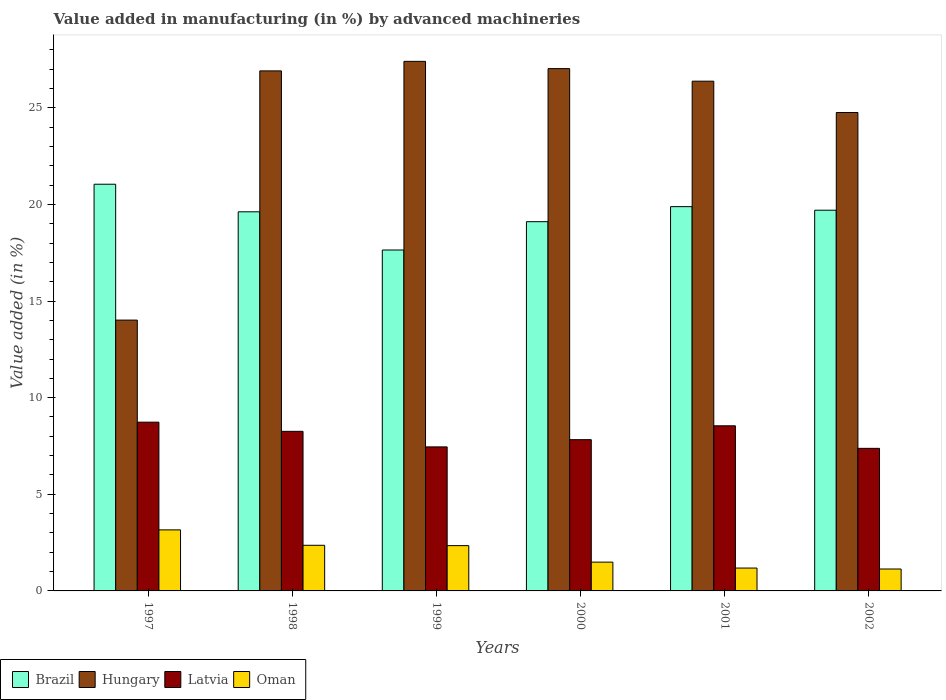How many different coloured bars are there?
Ensure brevity in your answer.  4. How many groups of bars are there?
Provide a short and direct response. 6. Are the number of bars on each tick of the X-axis equal?
Ensure brevity in your answer.  Yes. What is the label of the 1st group of bars from the left?
Make the answer very short. 1997. In how many cases, is the number of bars for a given year not equal to the number of legend labels?
Offer a very short reply. 0. What is the percentage of value added in manufacturing by advanced machineries in Oman in 1997?
Offer a terse response. 3.16. Across all years, what is the maximum percentage of value added in manufacturing by advanced machineries in Latvia?
Provide a succinct answer. 8.73. Across all years, what is the minimum percentage of value added in manufacturing by advanced machineries in Brazil?
Your response must be concise. 17.64. In which year was the percentage of value added in manufacturing by advanced machineries in Brazil maximum?
Provide a succinct answer. 1997. In which year was the percentage of value added in manufacturing by advanced machineries in Brazil minimum?
Make the answer very short. 1999. What is the total percentage of value added in manufacturing by advanced machineries in Oman in the graph?
Give a very brief answer. 11.67. What is the difference between the percentage of value added in manufacturing by advanced machineries in Hungary in 1997 and that in 2002?
Give a very brief answer. -10.74. What is the difference between the percentage of value added in manufacturing by advanced machineries in Hungary in 2001 and the percentage of value added in manufacturing by advanced machineries in Oman in 2002?
Provide a succinct answer. 25.24. What is the average percentage of value added in manufacturing by advanced machineries in Latvia per year?
Your answer should be very brief. 8.03. In the year 2000, what is the difference between the percentage of value added in manufacturing by advanced machineries in Oman and percentage of value added in manufacturing by advanced machineries in Hungary?
Offer a terse response. -25.54. In how many years, is the percentage of value added in manufacturing by advanced machineries in Oman greater than 25 %?
Provide a succinct answer. 0. What is the ratio of the percentage of value added in manufacturing by advanced machineries in Oman in 1997 to that in 1999?
Your response must be concise. 1.35. What is the difference between the highest and the second highest percentage of value added in manufacturing by advanced machineries in Brazil?
Your response must be concise. 1.16. What is the difference between the highest and the lowest percentage of value added in manufacturing by advanced machineries in Brazil?
Your response must be concise. 3.4. Is the sum of the percentage of value added in manufacturing by advanced machineries in Hungary in 1999 and 2000 greater than the maximum percentage of value added in manufacturing by advanced machineries in Oman across all years?
Make the answer very short. Yes. Is it the case that in every year, the sum of the percentage of value added in manufacturing by advanced machineries in Oman and percentage of value added in manufacturing by advanced machineries in Hungary is greater than the sum of percentage of value added in manufacturing by advanced machineries in Brazil and percentage of value added in manufacturing by advanced machineries in Latvia?
Offer a terse response. No. What does the 3rd bar from the left in 2000 represents?
Offer a terse response. Latvia. What does the 1st bar from the right in 2002 represents?
Your answer should be compact. Oman. Are all the bars in the graph horizontal?
Provide a short and direct response. No. How many years are there in the graph?
Your answer should be very brief. 6. Are the values on the major ticks of Y-axis written in scientific E-notation?
Your answer should be very brief. No. How are the legend labels stacked?
Your answer should be very brief. Horizontal. What is the title of the graph?
Offer a terse response. Value added in manufacturing (in %) by advanced machineries. Does "Bosnia and Herzegovina" appear as one of the legend labels in the graph?
Make the answer very short. No. What is the label or title of the X-axis?
Offer a very short reply. Years. What is the label or title of the Y-axis?
Ensure brevity in your answer.  Value added (in %). What is the Value added (in %) in Brazil in 1997?
Your answer should be compact. 21.04. What is the Value added (in %) in Hungary in 1997?
Provide a short and direct response. 14.01. What is the Value added (in %) of Latvia in 1997?
Keep it short and to the point. 8.73. What is the Value added (in %) of Oman in 1997?
Offer a very short reply. 3.16. What is the Value added (in %) in Brazil in 1998?
Offer a terse response. 19.62. What is the Value added (in %) in Hungary in 1998?
Keep it short and to the point. 26.91. What is the Value added (in %) of Latvia in 1998?
Your answer should be compact. 8.26. What is the Value added (in %) of Oman in 1998?
Offer a terse response. 2.36. What is the Value added (in %) in Brazil in 1999?
Your answer should be very brief. 17.64. What is the Value added (in %) in Hungary in 1999?
Ensure brevity in your answer.  27.4. What is the Value added (in %) of Latvia in 1999?
Your answer should be compact. 7.45. What is the Value added (in %) of Oman in 1999?
Ensure brevity in your answer.  2.34. What is the Value added (in %) of Brazil in 2000?
Keep it short and to the point. 19.11. What is the Value added (in %) of Hungary in 2000?
Your answer should be compact. 27.03. What is the Value added (in %) in Latvia in 2000?
Make the answer very short. 7.83. What is the Value added (in %) in Oman in 2000?
Provide a succinct answer. 1.49. What is the Value added (in %) in Brazil in 2001?
Offer a terse response. 19.88. What is the Value added (in %) of Hungary in 2001?
Your answer should be very brief. 26.38. What is the Value added (in %) of Latvia in 2001?
Provide a succinct answer. 8.54. What is the Value added (in %) of Oman in 2001?
Your answer should be compact. 1.18. What is the Value added (in %) in Brazil in 2002?
Your answer should be very brief. 19.7. What is the Value added (in %) of Hungary in 2002?
Your answer should be compact. 24.76. What is the Value added (in %) of Latvia in 2002?
Provide a short and direct response. 7.38. What is the Value added (in %) in Oman in 2002?
Your response must be concise. 1.13. Across all years, what is the maximum Value added (in %) in Brazil?
Offer a very short reply. 21.04. Across all years, what is the maximum Value added (in %) in Hungary?
Keep it short and to the point. 27.4. Across all years, what is the maximum Value added (in %) in Latvia?
Your answer should be very brief. 8.73. Across all years, what is the maximum Value added (in %) in Oman?
Make the answer very short. 3.16. Across all years, what is the minimum Value added (in %) of Brazil?
Provide a short and direct response. 17.64. Across all years, what is the minimum Value added (in %) in Hungary?
Make the answer very short. 14.01. Across all years, what is the minimum Value added (in %) of Latvia?
Your answer should be very brief. 7.38. Across all years, what is the minimum Value added (in %) of Oman?
Ensure brevity in your answer.  1.13. What is the total Value added (in %) of Brazil in the graph?
Provide a succinct answer. 116.99. What is the total Value added (in %) of Hungary in the graph?
Provide a short and direct response. 146.48. What is the total Value added (in %) of Latvia in the graph?
Ensure brevity in your answer.  48.19. What is the total Value added (in %) of Oman in the graph?
Offer a very short reply. 11.67. What is the difference between the Value added (in %) of Brazil in 1997 and that in 1998?
Your answer should be compact. 1.43. What is the difference between the Value added (in %) of Hungary in 1997 and that in 1998?
Give a very brief answer. -12.9. What is the difference between the Value added (in %) of Latvia in 1997 and that in 1998?
Your answer should be very brief. 0.47. What is the difference between the Value added (in %) in Oman in 1997 and that in 1998?
Give a very brief answer. 0.8. What is the difference between the Value added (in %) in Brazil in 1997 and that in 1999?
Ensure brevity in your answer.  3.4. What is the difference between the Value added (in %) of Hungary in 1997 and that in 1999?
Keep it short and to the point. -13.39. What is the difference between the Value added (in %) of Latvia in 1997 and that in 1999?
Make the answer very short. 1.28. What is the difference between the Value added (in %) of Oman in 1997 and that in 1999?
Make the answer very short. 0.82. What is the difference between the Value added (in %) in Brazil in 1997 and that in 2000?
Your response must be concise. 1.94. What is the difference between the Value added (in %) of Hungary in 1997 and that in 2000?
Make the answer very short. -13.01. What is the difference between the Value added (in %) of Latvia in 1997 and that in 2000?
Your answer should be compact. 0.91. What is the difference between the Value added (in %) in Oman in 1997 and that in 2000?
Keep it short and to the point. 1.67. What is the difference between the Value added (in %) of Brazil in 1997 and that in 2001?
Offer a terse response. 1.16. What is the difference between the Value added (in %) of Hungary in 1997 and that in 2001?
Provide a short and direct response. -12.36. What is the difference between the Value added (in %) in Latvia in 1997 and that in 2001?
Provide a short and direct response. 0.19. What is the difference between the Value added (in %) of Oman in 1997 and that in 2001?
Your answer should be compact. 1.98. What is the difference between the Value added (in %) in Brazil in 1997 and that in 2002?
Your answer should be compact. 1.34. What is the difference between the Value added (in %) in Hungary in 1997 and that in 2002?
Keep it short and to the point. -10.74. What is the difference between the Value added (in %) of Latvia in 1997 and that in 2002?
Make the answer very short. 1.35. What is the difference between the Value added (in %) of Oman in 1997 and that in 2002?
Your response must be concise. 2.03. What is the difference between the Value added (in %) of Brazil in 1998 and that in 1999?
Offer a terse response. 1.98. What is the difference between the Value added (in %) of Hungary in 1998 and that in 1999?
Your answer should be compact. -0.49. What is the difference between the Value added (in %) of Latvia in 1998 and that in 1999?
Your answer should be compact. 0.8. What is the difference between the Value added (in %) of Oman in 1998 and that in 1999?
Give a very brief answer. 0.02. What is the difference between the Value added (in %) of Brazil in 1998 and that in 2000?
Offer a terse response. 0.51. What is the difference between the Value added (in %) of Hungary in 1998 and that in 2000?
Keep it short and to the point. -0.12. What is the difference between the Value added (in %) in Latvia in 1998 and that in 2000?
Provide a short and direct response. 0.43. What is the difference between the Value added (in %) of Oman in 1998 and that in 2000?
Provide a short and direct response. 0.87. What is the difference between the Value added (in %) of Brazil in 1998 and that in 2001?
Make the answer very short. -0.27. What is the difference between the Value added (in %) in Hungary in 1998 and that in 2001?
Offer a terse response. 0.53. What is the difference between the Value added (in %) in Latvia in 1998 and that in 2001?
Give a very brief answer. -0.29. What is the difference between the Value added (in %) of Oman in 1998 and that in 2001?
Provide a succinct answer. 1.18. What is the difference between the Value added (in %) of Brazil in 1998 and that in 2002?
Give a very brief answer. -0.08. What is the difference between the Value added (in %) in Hungary in 1998 and that in 2002?
Offer a very short reply. 2.15. What is the difference between the Value added (in %) in Latvia in 1998 and that in 2002?
Your answer should be compact. 0.88. What is the difference between the Value added (in %) in Oman in 1998 and that in 2002?
Make the answer very short. 1.23. What is the difference between the Value added (in %) in Brazil in 1999 and that in 2000?
Your answer should be very brief. -1.47. What is the difference between the Value added (in %) of Hungary in 1999 and that in 2000?
Provide a succinct answer. 0.38. What is the difference between the Value added (in %) in Latvia in 1999 and that in 2000?
Make the answer very short. -0.37. What is the difference between the Value added (in %) in Oman in 1999 and that in 2000?
Offer a very short reply. 0.85. What is the difference between the Value added (in %) of Brazil in 1999 and that in 2001?
Your response must be concise. -2.24. What is the difference between the Value added (in %) in Hungary in 1999 and that in 2001?
Make the answer very short. 1.03. What is the difference between the Value added (in %) of Latvia in 1999 and that in 2001?
Make the answer very short. -1.09. What is the difference between the Value added (in %) of Oman in 1999 and that in 2001?
Offer a very short reply. 1.16. What is the difference between the Value added (in %) of Brazil in 1999 and that in 2002?
Offer a terse response. -2.06. What is the difference between the Value added (in %) in Hungary in 1999 and that in 2002?
Provide a succinct answer. 2.65. What is the difference between the Value added (in %) of Latvia in 1999 and that in 2002?
Keep it short and to the point. 0.08. What is the difference between the Value added (in %) in Oman in 1999 and that in 2002?
Your answer should be compact. 1.21. What is the difference between the Value added (in %) of Brazil in 2000 and that in 2001?
Your answer should be very brief. -0.78. What is the difference between the Value added (in %) in Hungary in 2000 and that in 2001?
Provide a short and direct response. 0.65. What is the difference between the Value added (in %) in Latvia in 2000 and that in 2001?
Provide a succinct answer. -0.72. What is the difference between the Value added (in %) in Oman in 2000 and that in 2001?
Ensure brevity in your answer.  0.31. What is the difference between the Value added (in %) in Brazil in 2000 and that in 2002?
Offer a very short reply. -0.59. What is the difference between the Value added (in %) of Hungary in 2000 and that in 2002?
Provide a short and direct response. 2.27. What is the difference between the Value added (in %) in Latvia in 2000 and that in 2002?
Your response must be concise. 0.45. What is the difference between the Value added (in %) of Oman in 2000 and that in 2002?
Your response must be concise. 0.36. What is the difference between the Value added (in %) of Brazil in 2001 and that in 2002?
Provide a short and direct response. 0.18. What is the difference between the Value added (in %) in Hungary in 2001 and that in 2002?
Give a very brief answer. 1.62. What is the difference between the Value added (in %) in Latvia in 2001 and that in 2002?
Your answer should be compact. 1.17. What is the difference between the Value added (in %) in Brazil in 1997 and the Value added (in %) in Hungary in 1998?
Your response must be concise. -5.86. What is the difference between the Value added (in %) in Brazil in 1997 and the Value added (in %) in Latvia in 1998?
Your answer should be very brief. 12.79. What is the difference between the Value added (in %) in Brazil in 1997 and the Value added (in %) in Oman in 1998?
Offer a very short reply. 18.68. What is the difference between the Value added (in %) in Hungary in 1997 and the Value added (in %) in Latvia in 1998?
Your answer should be very brief. 5.76. What is the difference between the Value added (in %) of Hungary in 1997 and the Value added (in %) of Oman in 1998?
Provide a succinct answer. 11.65. What is the difference between the Value added (in %) in Latvia in 1997 and the Value added (in %) in Oman in 1998?
Ensure brevity in your answer.  6.37. What is the difference between the Value added (in %) in Brazil in 1997 and the Value added (in %) in Hungary in 1999?
Your response must be concise. -6.36. What is the difference between the Value added (in %) of Brazil in 1997 and the Value added (in %) of Latvia in 1999?
Give a very brief answer. 13.59. What is the difference between the Value added (in %) of Brazil in 1997 and the Value added (in %) of Oman in 1999?
Ensure brevity in your answer.  18.7. What is the difference between the Value added (in %) in Hungary in 1997 and the Value added (in %) in Latvia in 1999?
Ensure brevity in your answer.  6.56. What is the difference between the Value added (in %) in Hungary in 1997 and the Value added (in %) in Oman in 1999?
Your answer should be very brief. 11.67. What is the difference between the Value added (in %) in Latvia in 1997 and the Value added (in %) in Oman in 1999?
Provide a succinct answer. 6.39. What is the difference between the Value added (in %) in Brazil in 1997 and the Value added (in %) in Hungary in 2000?
Give a very brief answer. -5.98. What is the difference between the Value added (in %) of Brazil in 1997 and the Value added (in %) of Latvia in 2000?
Offer a terse response. 13.22. What is the difference between the Value added (in %) of Brazil in 1997 and the Value added (in %) of Oman in 2000?
Keep it short and to the point. 19.56. What is the difference between the Value added (in %) in Hungary in 1997 and the Value added (in %) in Latvia in 2000?
Offer a terse response. 6.19. What is the difference between the Value added (in %) in Hungary in 1997 and the Value added (in %) in Oman in 2000?
Provide a succinct answer. 12.52. What is the difference between the Value added (in %) in Latvia in 1997 and the Value added (in %) in Oman in 2000?
Provide a short and direct response. 7.24. What is the difference between the Value added (in %) in Brazil in 1997 and the Value added (in %) in Hungary in 2001?
Your answer should be compact. -5.33. What is the difference between the Value added (in %) of Brazil in 1997 and the Value added (in %) of Latvia in 2001?
Keep it short and to the point. 12.5. What is the difference between the Value added (in %) in Brazil in 1997 and the Value added (in %) in Oman in 2001?
Give a very brief answer. 19.86. What is the difference between the Value added (in %) in Hungary in 1997 and the Value added (in %) in Latvia in 2001?
Give a very brief answer. 5.47. What is the difference between the Value added (in %) in Hungary in 1997 and the Value added (in %) in Oman in 2001?
Make the answer very short. 12.83. What is the difference between the Value added (in %) of Latvia in 1997 and the Value added (in %) of Oman in 2001?
Offer a very short reply. 7.55. What is the difference between the Value added (in %) of Brazil in 1997 and the Value added (in %) of Hungary in 2002?
Ensure brevity in your answer.  -3.71. What is the difference between the Value added (in %) of Brazil in 1997 and the Value added (in %) of Latvia in 2002?
Offer a terse response. 13.67. What is the difference between the Value added (in %) of Brazil in 1997 and the Value added (in %) of Oman in 2002?
Provide a short and direct response. 19.91. What is the difference between the Value added (in %) of Hungary in 1997 and the Value added (in %) of Latvia in 2002?
Provide a short and direct response. 6.64. What is the difference between the Value added (in %) of Hungary in 1997 and the Value added (in %) of Oman in 2002?
Your answer should be very brief. 12.88. What is the difference between the Value added (in %) of Latvia in 1997 and the Value added (in %) of Oman in 2002?
Ensure brevity in your answer.  7.6. What is the difference between the Value added (in %) in Brazil in 1998 and the Value added (in %) in Hungary in 1999?
Make the answer very short. -7.79. What is the difference between the Value added (in %) of Brazil in 1998 and the Value added (in %) of Latvia in 1999?
Offer a terse response. 12.16. What is the difference between the Value added (in %) in Brazil in 1998 and the Value added (in %) in Oman in 1999?
Offer a terse response. 17.27. What is the difference between the Value added (in %) in Hungary in 1998 and the Value added (in %) in Latvia in 1999?
Your response must be concise. 19.46. What is the difference between the Value added (in %) of Hungary in 1998 and the Value added (in %) of Oman in 1999?
Make the answer very short. 24.57. What is the difference between the Value added (in %) in Latvia in 1998 and the Value added (in %) in Oman in 1999?
Offer a very short reply. 5.91. What is the difference between the Value added (in %) in Brazil in 1998 and the Value added (in %) in Hungary in 2000?
Your answer should be very brief. -7.41. What is the difference between the Value added (in %) in Brazil in 1998 and the Value added (in %) in Latvia in 2000?
Ensure brevity in your answer.  11.79. What is the difference between the Value added (in %) of Brazil in 1998 and the Value added (in %) of Oman in 2000?
Ensure brevity in your answer.  18.13. What is the difference between the Value added (in %) of Hungary in 1998 and the Value added (in %) of Latvia in 2000?
Make the answer very short. 19.08. What is the difference between the Value added (in %) in Hungary in 1998 and the Value added (in %) in Oman in 2000?
Provide a succinct answer. 25.42. What is the difference between the Value added (in %) of Latvia in 1998 and the Value added (in %) of Oman in 2000?
Keep it short and to the point. 6.77. What is the difference between the Value added (in %) in Brazil in 1998 and the Value added (in %) in Hungary in 2001?
Your response must be concise. -6.76. What is the difference between the Value added (in %) in Brazil in 1998 and the Value added (in %) in Latvia in 2001?
Offer a terse response. 11.07. What is the difference between the Value added (in %) in Brazil in 1998 and the Value added (in %) in Oman in 2001?
Your answer should be very brief. 18.43. What is the difference between the Value added (in %) of Hungary in 1998 and the Value added (in %) of Latvia in 2001?
Ensure brevity in your answer.  18.36. What is the difference between the Value added (in %) in Hungary in 1998 and the Value added (in %) in Oman in 2001?
Give a very brief answer. 25.73. What is the difference between the Value added (in %) in Latvia in 1998 and the Value added (in %) in Oman in 2001?
Your answer should be compact. 7.07. What is the difference between the Value added (in %) of Brazil in 1998 and the Value added (in %) of Hungary in 2002?
Offer a very short reply. -5.14. What is the difference between the Value added (in %) in Brazil in 1998 and the Value added (in %) in Latvia in 2002?
Your answer should be very brief. 12.24. What is the difference between the Value added (in %) in Brazil in 1998 and the Value added (in %) in Oman in 2002?
Keep it short and to the point. 18.48. What is the difference between the Value added (in %) of Hungary in 1998 and the Value added (in %) of Latvia in 2002?
Your answer should be compact. 19.53. What is the difference between the Value added (in %) of Hungary in 1998 and the Value added (in %) of Oman in 2002?
Keep it short and to the point. 25.78. What is the difference between the Value added (in %) in Latvia in 1998 and the Value added (in %) in Oman in 2002?
Provide a short and direct response. 7.12. What is the difference between the Value added (in %) in Brazil in 1999 and the Value added (in %) in Hungary in 2000?
Your response must be concise. -9.39. What is the difference between the Value added (in %) of Brazil in 1999 and the Value added (in %) of Latvia in 2000?
Keep it short and to the point. 9.81. What is the difference between the Value added (in %) of Brazil in 1999 and the Value added (in %) of Oman in 2000?
Provide a succinct answer. 16.15. What is the difference between the Value added (in %) in Hungary in 1999 and the Value added (in %) in Latvia in 2000?
Your response must be concise. 19.58. What is the difference between the Value added (in %) of Hungary in 1999 and the Value added (in %) of Oman in 2000?
Provide a succinct answer. 25.91. What is the difference between the Value added (in %) of Latvia in 1999 and the Value added (in %) of Oman in 2000?
Your response must be concise. 5.96. What is the difference between the Value added (in %) in Brazil in 1999 and the Value added (in %) in Hungary in 2001?
Provide a short and direct response. -8.74. What is the difference between the Value added (in %) of Brazil in 1999 and the Value added (in %) of Latvia in 2001?
Your answer should be very brief. 9.1. What is the difference between the Value added (in %) of Brazil in 1999 and the Value added (in %) of Oman in 2001?
Provide a short and direct response. 16.46. What is the difference between the Value added (in %) of Hungary in 1999 and the Value added (in %) of Latvia in 2001?
Provide a succinct answer. 18.86. What is the difference between the Value added (in %) in Hungary in 1999 and the Value added (in %) in Oman in 2001?
Your answer should be compact. 26.22. What is the difference between the Value added (in %) of Latvia in 1999 and the Value added (in %) of Oman in 2001?
Make the answer very short. 6.27. What is the difference between the Value added (in %) of Brazil in 1999 and the Value added (in %) of Hungary in 2002?
Provide a short and direct response. -7.12. What is the difference between the Value added (in %) of Brazil in 1999 and the Value added (in %) of Latvia in 2002?
Keep it short and to the point. 10.26. What is the difference between the Value added (in %) in Brazil in 1999 and the Value added (in %) in Oman in 2002?
Make the answer very short. 16.51. What is the difference between the Value added (in %) in Hungary in 1999 and the Value added (in %) in Latvia in 2002?
Offer a terse response. 20.02. What is the difference between the Value added (in %) in Hungary in 1999 and the Value added (in %) in Oman in 2002?
Offer a terse response. 26.27. What is the difference between the Value added (in %) in Latvia in 1999 and the Value added (in %) in Oman in 2002?
Your response must be concise. 6.32. What is the difference between the Value added (in %) in Brazil in 2000 and the Value added (in %) in Hungary in 2001?
Your response must be concise. -7.27. What is the difference between the Value added (in %) of Brazil in 2000 and the Value added (in %) of Latvia in 2001?
Your answer should be compact. 10.56. What is the difference between the Value added (in %) in Brazil in 2000 and the Value added (in %) in Oman in 2001?
Your answer should be very brief. 17.92. What is the difference between the Value added (in %) in Hungary in 2000 and the Value added (in %) in Latvia in 2001?
Provide a short and direct response. 18.48. What is the difference between the Value added (in %) of Hungary in 2000 and the Value added (in %) of Oman in 2001?
Make the answer very short. 25.84. What is the difference between the Value added (in %) of Latvia in 2000 and the Value added (in %) of Oman in 2001?
Ensure brevity in your answer.  6.64. What is the difference between the Value added (in %) in Brazil in 2000 and the Value added (in %) in Hungary in 2002?
Offer a very short reply. -5.65. What is the difference between the Value added (in %) of Brazil in 2000 and the Value added (in %) of Latvia in 2002?
Your answer should be very brief. 11.73. What is the difference between the Value added (in %) of Brazil in 2000 and the Value added (in %) of Oman in 2002?
Your answer should be very brief. 17.97. What is the difference between the Value added (in %) of Hungary in 2000 and the Value added (in %) of Latvia in 2002?
Give a very brief answer. 19.65. What is the difference between the Value added (in %) in Hungary in 2000 and the Value added (in %) in Oman in 2002?
Give a very brief answer. 25.89. What is the difference between the Value added (in %) in Latvia in 2000 and the Value added (in %) in Oman in 2002?
Offer a very short reply. 6.69. What is the difference between the Value added (in %) in Brazil in 2001 and the Value added (in %) in Hungary in 2002?
Keep it short and to the point. -4.87. What is the difference between the Value added (in %) of Brazil in 2001 and the Value added (in %) of Latvia in 2002?
Your response must be concise. 12.51. What is the difference between the Value added (in %) of Brazil in 2001 and the Value added (in %) of Oman in 2002?
Make the answer very short. 18.75. What is the difference between the Value added (in %) of Hungary in 2001 and the Value added (in %) of Latvia in 2002?
Offer a terse response. 19. What is the difference between the Value added (in %) in Hungary in 2001 and the Value added (in %) in Oman in 2002?
Make the answer very short. 25.24. What is the difference between the Value added (in %) of Latvia in 2001 and the Value added (in %) of Oman in 2002?
Your response must be concise. 7.41. What is the average Value added (in %) of Brazil per year?
Make the answer very short. 19.5. What is the average Value added (in %) in Hungary per year?
Offer a terse response. 24.41. What is the average Value added (in %) in Latvia per year?
Your answer should be compact. 8.03. What is the average Value added (in %) in Oman per year?
Offer a terse response. 1.94. In the year 1997, what is the difference between the Value added (in %) in Brazil and Value added (in %) in Hungary?
Offer a terse response. 7.03. In the year 1997, what is the difference between the Value added (in %) in Brazil and Value added (in %) in Latvia?
Make the answer very short. 12.31. In the year 1997, what is the difference between the Value added (in %) of Brazil and Value added (in %) of Oman?
Your answer should be compact. 17.89. In the year 1997, what is the difference between the Value added (in %) of Hungary and Value added (in %) of Latvia?
Make the answer very short. 5.28. In the year 1997, what is the difference between the Value added (in %) of Hungary and Value added (in %) of Oman?
Provide a succinct answer. 10.85. In the year 1997, what is the difference between the Value added (in %) in Latvia and Value added (in %) in Oman?
Keep it short and to the point. 5.57. In the year 1998, what is the difference between the Value added (in %) of Brazil and Value added (in %) of Hungary?
Offer a very short reply. -7.29. In the year 1998, what is the difference between the Value added (in %) of Brazil and Value added (in %) of Latvia?
Your answer should be very brief. 11.36. In the year 1998, what is the difference between the Value added (in %) of Brazil and Value added (in %) of Oman?
Ensure brevity in your answer.  17.26. In the year 1998, what is the difference between the Value added (in %) in Hungary and Value added (in %) in Latvia?
Your answer should be compact. 18.65. In the year 1998, what is the difference between the Value added (in %) in Hungary and Value added (in %) in Oman?
Make the answer very short. 24.55. In the year 1998, what is the difference between the Value added (in %) in Latvia and Value added (in %) in Oman?
Offer a very short reply. 5.9. In the year 1999, what is the difference between the Value added (in %) in Brazil and Value added (in %) in Hungary?
Your answer should be very brief. -9.76. In the year 1999, what is the difference between the Value added (in %) of Brazil and Value added (in %) of Latvia?
Keep it short and to the point. 10.19. In the year 1999, what is the difference between the Value added (in %) of Brazil and Value added (in %) of Oman?
Give a very brief answer. 15.3. In the year 1999, what is the difference between the Value added (in %) of Hungary and Value added (in %) of Latvia?
Your answer should be very brief. 19.95. In the year 1999, what is the difference between the Value added (in %) in Hungary and Value added (in %) in Oman?
Keep it short and to the point. 25.06. In the year 1999, what is the difference between the Value added (in %) of Latvia and Value added (in %) of Oman?
Offer a very short reply. 5.11. In the year 2000, what is the difference between the Value added (in %) of Brazil and Value added (in %) of Hungary?
Provide a succinct answer. -7.92. In the year 2000, what is the difference between the Value added (in %) of Brazil and Value added (in %) of Latvia?
Ensure brevity in your answer.  11.28. In the year 2000, what is the difference between the Value added (in %) of Brazil and Value added (in %) of Oman?
Provide a succinct answer. 17.62. In the year 2000, what is the difference between the Value added (in %) in Hungary and Value added (in %) in Latvia?
Offer a terse response. 19.2. In the year 2000, what is the difference between the Value added (in %) of Hungary and Value added (in %) of Oman?
Ensure brevity in your answer.  25.54. In the year 2000, what is the difference between the Value added (in %) in Latvia and Value added (in %) in Oman?
Your answer should be compact. 6.34. In the year 2001, what is the difference between the Value added (in %) in Brazil and Value added (in %) in Hungary?
Ensure brevity in your answer.  -6.49. In the year 2001, what is the difference between the Value added (in %) of Brazil and Value added (in %) of Latvia?
Ensure brevity in your answer.  11.34. In the year 2001, what is the difference between the Value added (in %) of Brazil and Value added (in %) of Oman?
Make the answer very short. 18.7. In the year 2001, what is the difference between the Value added (in %) of Hungary and Value added (in %) of Latvia?
Offer a terse response. 17.83. In the year 2001, what is the difference between the Value added (in %) in Hungary and Value added (in %) in Oman?
Give a very brief answer. 25.19. In the year 2001, what is the difference between the Value added (in %) of Latvia and Value added (in %) of Oman?
Your response must be concise. 7.36. In the year 2002, what is the difference between the Value added (in %) of Brazil and Value added (in %) of Hungary?
Your response must be concise. -5.06. In the year 2002, what is the difference between the Value added (in %) in Brazil and Value added (in %) in Latvia?
Make the answer very short. 12.32. In the year 2002, what is the difference between the Value added (in %) of Brazil and Value added (in %) of Oman?
Your response must be concise. 18.57. In the year 2002, what is the difference between the Value added (in %) of Hungary and Value added (in %) of Latvia?
Your answer should be very brief. 17.38. In the year 2002, what is the difference between the Value added (in %) of Hungary and Value added (in %) of Oman?
Provide a succinct answer. 23.62. In the year 2002, what is the difference between the Value added (in %) of Latvia and Value added (in %) of Oman?
Offer a very short reply. 6.24. What is the ratio of the Value added (in %) of Brazil in 1997 to that in 1998?
Ensure brevity in your answer.  1.07. What is the ratio of the Value added (in %) of Hungary in 1997 to that in 1998?
Your answer should be compact. 0.52. What is the ratio of the Value added (in %) in Latvia in 1997 to that in 1998?
Make the answer very short. 1.06. What is the ratio of the Value added (in %) of Oman in 1997 to that in 1998?
Keep it short and to the point. 1.34. What is the ratio of the Value added (in %) in Brazil in 1997 to that in 1999?
Provide a short and direct response. 1.19. What is the ratio of the Value added (in %) in Hungary in 1997 to that in 1999?
Give a very brief answer. 0.51. What is the ratio of the Value added (in %) of Latvia in 1997 to that in 1999?
Keep it short and to the point. 1.17. What is the ratio of the Value added (in %) in Oman in 1997 to that in 1999?
Provide a short and direct response. 1.35. What is the ratio of the Value added (in %) in Brazil in 1997 to that in 2000?
Ensure brevity in your answer.  1.1. What is the ratio of the Value added (in %) in Hungary in 1997 to that in 2000?
Your answer should be compact. 0.52. What is the ratio of the Value added (in %) of Latvia in 1997 to that in 2000?
Keep it short and to the point. 1.12. What is the ratio of the Value added (in %) in Oman in 1997 to that in 2000?
Offer a terse response. 2.12. What is the ratio of the Value added (in %) in Brazil in 1997 to that in 2001?
Ensure brevity in your answer.  1.06. What is the ratio of the Value added (in %) in Hungary in 1997 to that in 2001?
Your answer should be compact. 0.53. What is the ratio of the Value added (in %) of Latvia in 1997 to that in 2001?
Your response must be concise. 1.02. What is the ratio of the Value added (in %) in Oman in 1997 to that in 2001?
Your answer should be very brief. 2.67. What is the ratio of the Value added (in %) in Brazil in 1997 to that in 2002?
Offer a very short reply. 1.07. What is the ratio of the Value added (in %) in Hungary in 1997 to that in 2002?
Your answer should be compact. 0.57. What is the ratio of the Value added (in %) in Latvia in 1997 to that in 2002?
Give a very brief answer. 1.18. What is the ratio of the Value added (in %) in Oman in 1997 to that in 2002?
Your answer should be very brief. 2.79. What is the ratio of the Value added (in %) in Brazil in 1998 to that in 1999?
Offer a very short reply. 1.11. What is the ratio of the Value added (in %) of Hungary in 1998 to that in 1999?
Offer a very short reply. 0.98. What is the ratio of the Value added (in %) of Latvia in 1998 to that in 1999?
Your answer should be compact. 1.11. What is the ratio of the Value added (in %) in Oman in 1998 to that in 1999?
Offer a very short reply. 1.01. What is the ratio of the Value added (in %) of Brazil in 1998 to that in 2000?
Make the answer very short. 1.03. What is the ratio of the Value added (in %) in Latvia in 1998 to that in 2000?
Give a very brief answer. 1.05. What is the ratio of the Value added (in %) of Oman in 1998 to that in 2000?
Provide a succinct answer. 1.59. What is the ratio of the Value added (in %) in Brazil in 1998 to that in 2001?
Make the answer very short. 0.99. What is the ratio of the Value added (in %) of Hungary in 1998 to that in 2001?
Ensure brevity in your answer.  1.02. What is the ratio of the Value added (in %) in Latvia in 1998 to that in 2001?
Offer a very short reply. 0.97. What is the ratio of the Value added (in %) of Oman in 1998 to that in 2001?
Offer a very short reply. 2. What is the ratio of the Value added (in %) in Brazil in 1998 to that in 2002?
Keep it short and to the point. 1. What is the ratio of the Value added (in %) of Hungary in 1998 to that in 2002?
Your answer should be very brief. 1.09. What is the ratio of the Value added (in %) in Latvia in 1998 to that in 2002?
Provide a succinct answer. 1.12. What is the ratio of the Value added (in %) in Oman in 1998 to that in 2002?
Give a very brief answer. 2.08. What is the ratio of the Value added (in %) in Brazil in 1999 to that in 2000?
Your response must be concise. 0.92. What is the ratio of the Value added (in %) of Hungary in 1999 to that in 2000?
Ensure brevity in your answer.  1.01. What is the ratio of the Value added (in %) of Latvia in 1999 to that in 2000?
Your answer should be very brief. 0.95. What is the ratio of the Value added (in %) in Oman in 1999 to that in 2000?
Ensure brevity in your answer.  1.57. What is the ratio of the Value added (in %) of Brazil in 1999 to that in 2001?
Your response must be concise. 0.89. What is the ratio of the Value added (in %) of Hungary in 1999 to that in 2001?
Keep it short and to the point. 1.04. What is the ratio of the Value added (in %) in Latvia in 1999 to that in 2001?
Offer a very short reply. 0.87. What is the ratio of the Value added (in %) of Oman in 1999 to that in 2001?
Provide a succinct answer. 1.98. What is the ratio of the Value added (in %) in Brazil in 1999 to that in 2002?
Offer a terse response. 0.9. What is the ratio of the Value added (in %) of Hungary in 1999 to that in 2002?
Your answer should be very brief. 1.11. What is the ratio of the Value added (in %) in Latvia in 1999 to that in 2002?
Give a very brief answer. 1.01. What is the ratio of the Value added (in %) in Oman in 1999 to that in 2002?
Provide a short and direct response. 2.07. What is the ratio of the Value added (in %) of Brazil in 2000 to that in 2001?
Provide a short and direct response. 0.96. What is the ratio of the Value added (in %) in Hungary in 2000 to that in 2001?
Offer a very short reply. 1.02. What is the ratio of the Value added (in %) of Latvia in 2000 to that in 2001?
Your answer should be very brief. 0.92. What is the ratio of the Value added (in %) of Oman in 2000 to that in 2001?
Keep it short and to the point. 1.26. What is the ratio of the Value added (in %) of Brazil in 2000 to that in 2002?
Your answer should be very brief. 0.97. What is the ratio of the Value added (in %) in Hungary in 2000 to that in 2002?
Provide a short and direct response. 1.09. What is the ratio of the Value added (in %) in Latvia in 2000 to that in 2002?
Give a very brief answer. 1.06. What is the ratio of the Value added (in %) of Oman in 2000 to that in 2002?
Keep it short and to the point. 1.31. What is the ratio of the Value added (in %) in Brazil in 2001 to that in 2002?
Give a very brief answer. 1.01. What is the ratio of the Value added (in %) of Hungary in 2001 to that in 2002?
Your answer should be very brief. 1.07. What is the ratio of the Value added (in %) of Latvia in 2001 to that in 2002?
Your answer should be compact. 1.16. What is the ratio of the Value added (in %) in Oman in 2001 to that in 2002?
Your response must be concise. 1.04. What is the difference between the highest and the second highest Value added (in %) of Brazil?
Ensure brevity in your answer.  1.16. What is the difference between the highest and the second highest Value added (in %) of Hungary?
Offer a very short reply. 0.38. What is the difference between the highest and the second highest Value added (in %) of Latvia?
Provide a short and direct response. 0.19. What is the difference between the highest and the second highest Value added (in %) of Oman?
Offer a very short reply. 0.8. What is the difference between the highest and the lowest Value added (in %) in Brazil?
Offer a terse response. 3.4. What is the difference between the highest and the lowest Value added (in %) in Hungary?
Provide a short and direct response. 13.39. What is the difference between the highest and the lowest Value added (in %) in Latvia?
Keep it short and to the point. 1.35. What is the difference between the highest and the lowest Value added (in %) in Oman?
Your answer should be very brief. 2.03. 